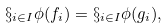Convert formula to latex. <formula><loc_0><loc_0><loc_500><loc_500>\S _ { i \in I } \phi ( f _ { i } ) = \S _ { i \in I } \phi ( g _ { i } ) ,</formula> 